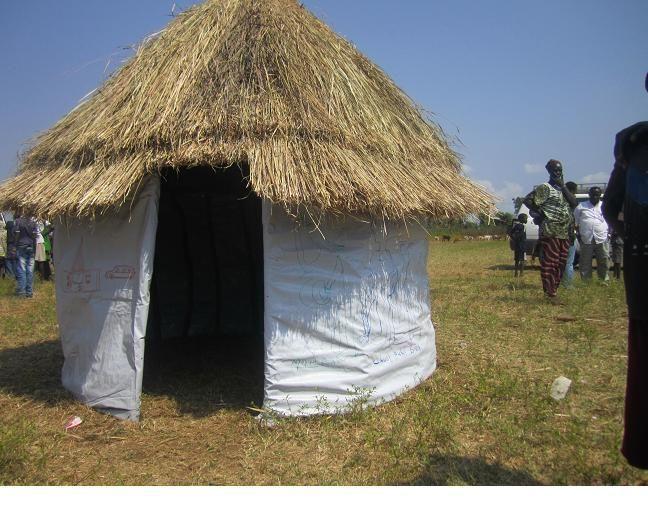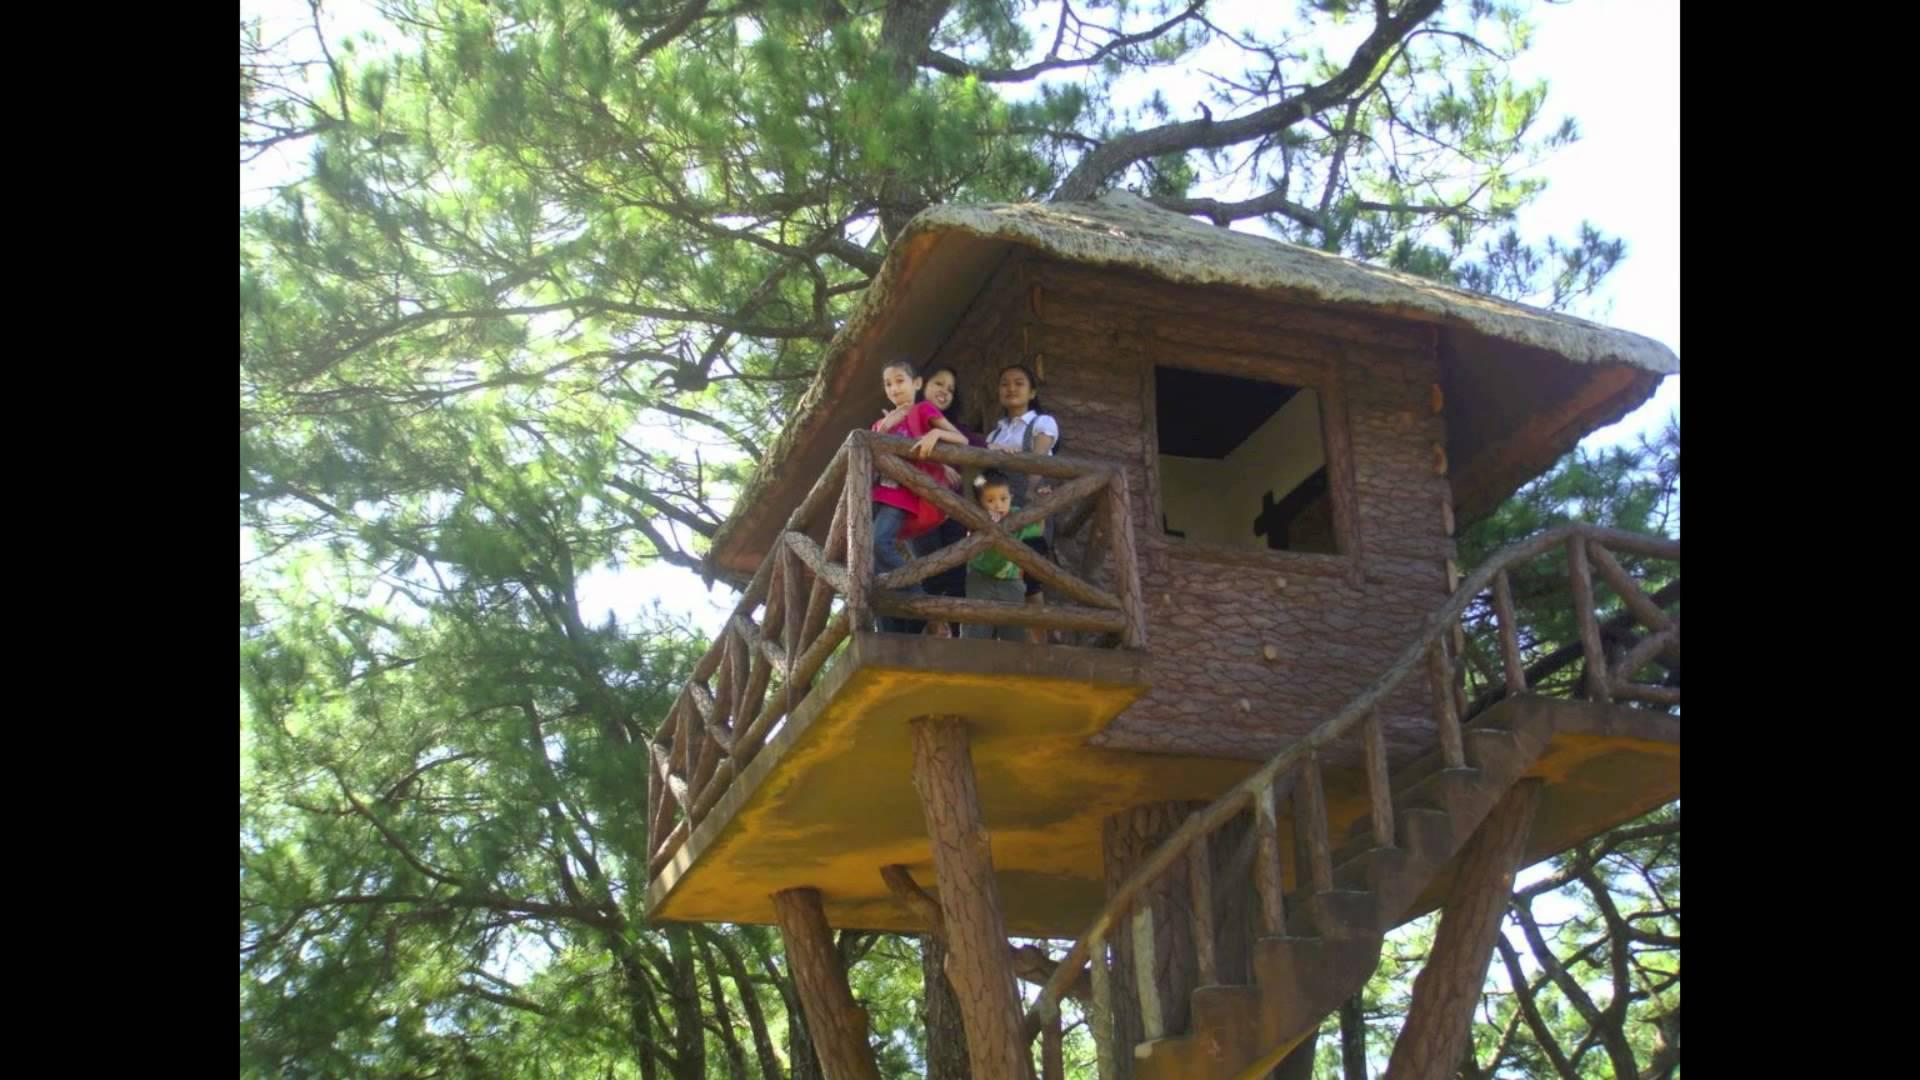The first image is the image on the left, the second image is the image on the right. Assess this claim about the two images: "The right image contains a tree house.". Correct or not? Answer yes or no. Yes. The first image is the image on the left, the second image is the image on the right. For the images displayed, is the sentence "A house with a thatched roof is up on stilts." factually correct? Answer yes or no. Yes. 